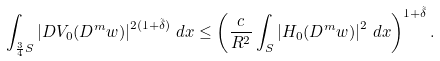Convert formula to latex. <formula><loc_0><loc_0><loc_500><loc_500>\int _ { \frac { 3 } { 4 } S } \left | D V _ { 0 } ( D ^ { m } w ) \right | ^ { 2 ( 1 + \tilde { \delta } ) } \, d x \leq \left ( \frac { c } { R ^ { 2 } } \int _ { S } \left | H _ { 0 } ( D ^ { m } w ) \right | ^ { 2 } \, d x \right ) ^ { 1 + \tilde { \delta } } .</formula> 